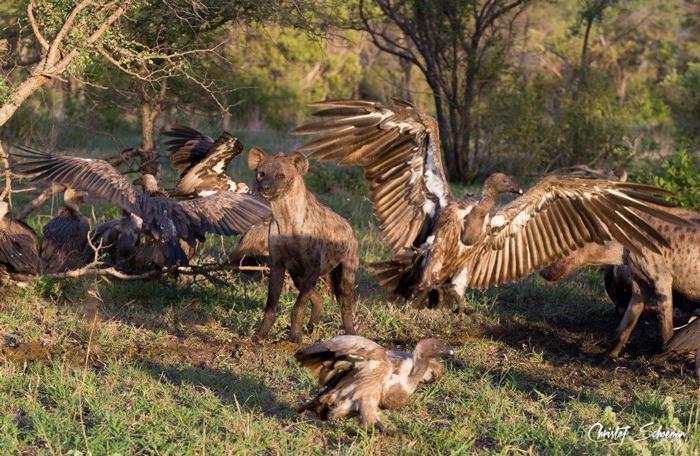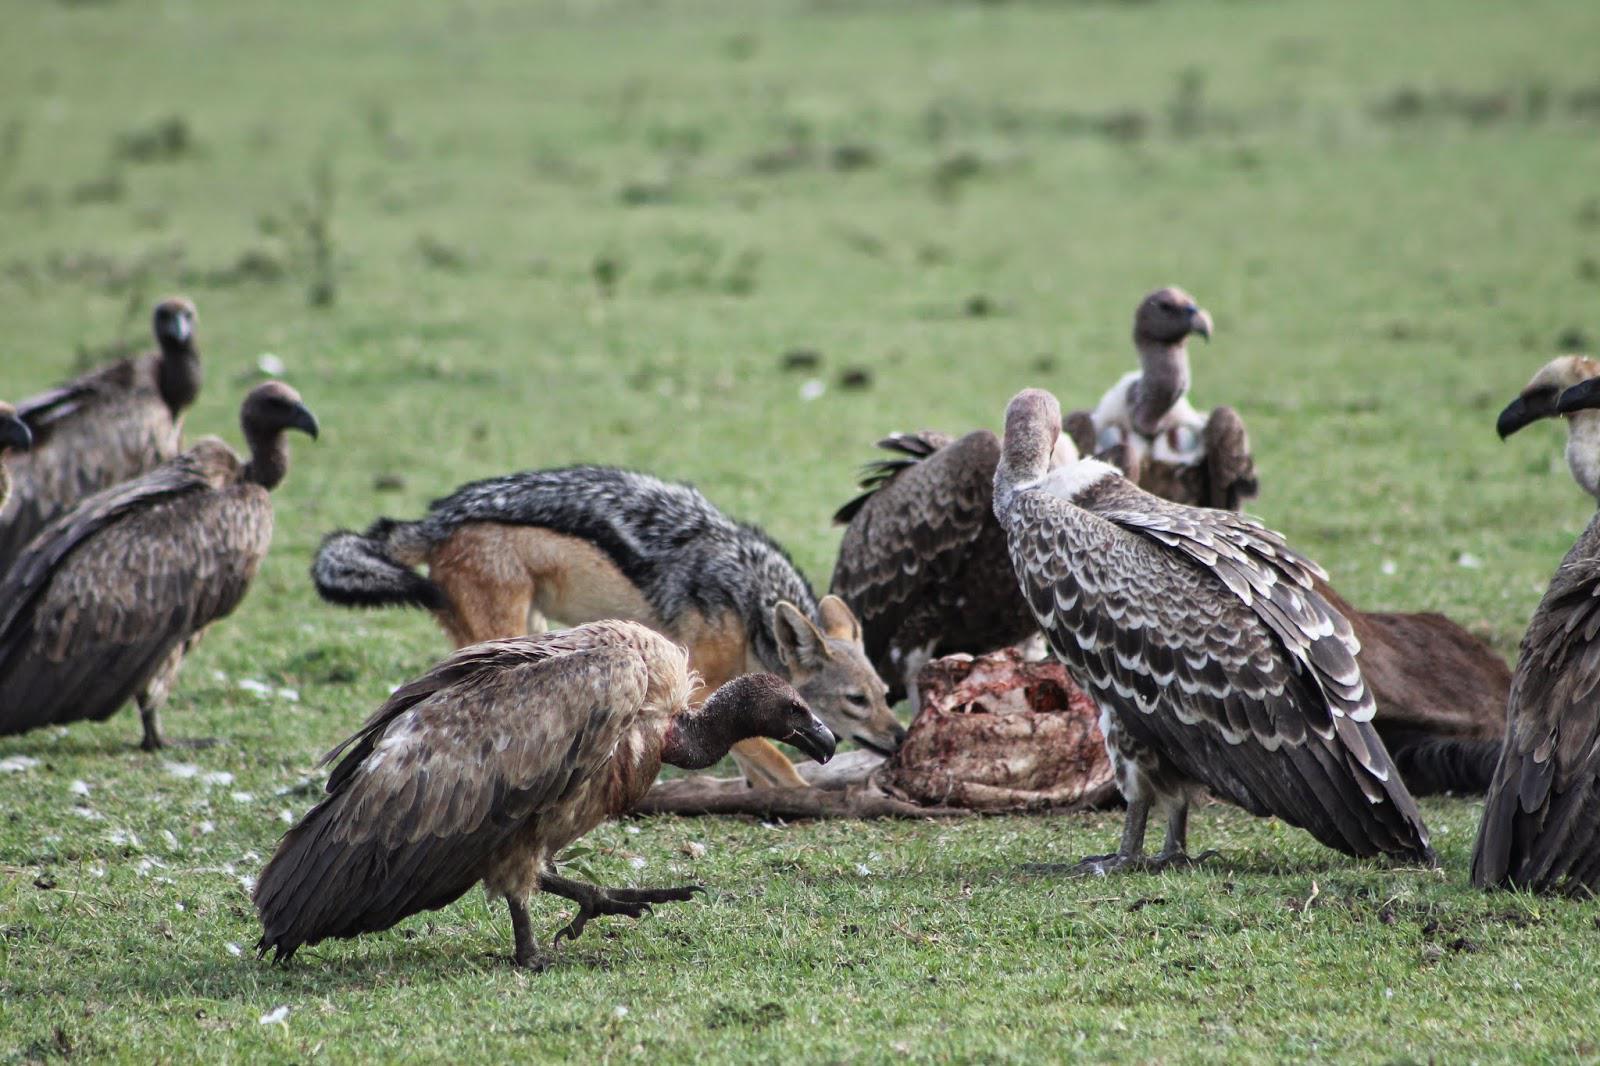The first image is the image on the left, the second image is the image on the right. Given the left and right images, does the statement "In one of the images, the animals are obviously feasting on zebra." hold true? Answer yes or no. No. 